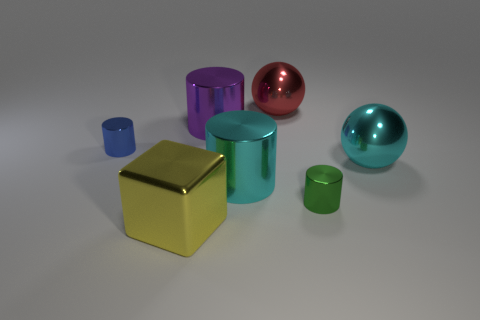What number of metal cylinders are on the left side of the large cylinder that is on the left side of the cyan cylinder?
Offer a very short reply. 1. Are there fewer metal blocks behind the cyan cylinder than cyan objects?
Your response must be concise. Yes. There is a cylinder that is behind the cylinder that is to the left of the large yellow metal thing; are there any big yellow blocks that are behind it?
Your response must be concise. No. Is the big cyan cylinder made of the same material as the big sphere to the right of the red metallic sphere?
Offer a terse response. Yes. There is a cylinder that is left of the large metal cylinder that is to the left of the big cyan cylinder; what color is it?
Give a very brief answer. Blue. Are there any tiny matte cylinders that have the same color as the cube?
Make the answer very short. No. What is the size of the metallic cylinder left of the big metal thing in front of the small metallic cylinder that is right of the large yellow object?
Keep it short and to the point. Small. Does the blue shiny object have the same shape as the small metallic thing that is on the right side of the yellow cube?
Offer a very short reply. Yes. How many other objects are the same size as the red metal object?
Your response must be concise. 4. There is a metallic object that is to the left of the big yellow metallic cube; what is its size?
Give a very brief answer. Small. 